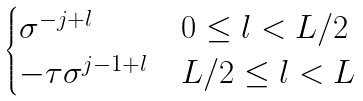Convert formula to latex. <formula><loc_0><loc_0><loc_500><loc_500>\begin{cases} \sigma ^ { - j + l } & 0 \leq l < L / 2 \\ - \tau \sigma ^ { j - 1 + l } & L / 2 \leq l < L \end{cases}</formula> 